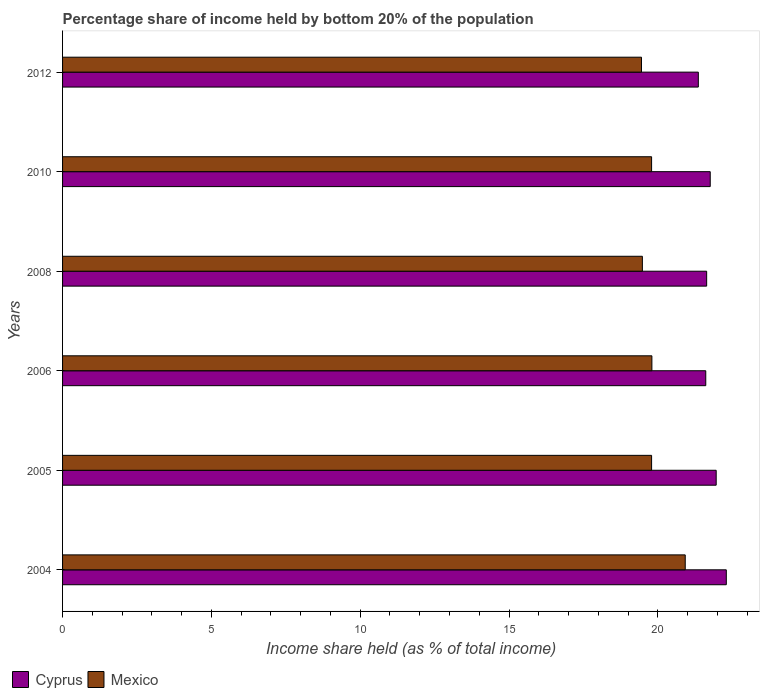How many different coloured bars are there?
Provide a short and direct response. 2. How many groups of bars are there?
Make the answer very short. 6. Are the number of bars on each tick of the Y-axis equal?
Provide a short and direct response. Yes. What is the label of the 6th group of bars from the top?
Ensure brevity in your answer.  2004. What is the share of income held by bottom 20% of the population in Cyprus in 2005?
Give a very brief answer. 21.96. Across all years, what is the maximum share of income held by bottom 20% of the population in Mexico?
Offer a very short reply. 20.92. Across all years, what is the minimum share of income held by bottom 20% of the population in Cyprus?
Your answer should be very brief. 21.36. What is the total share of income held by bottom 20% of the population in Cyprus in the graph?
Offer a terse response. 130.63. What is the difference between the share of income held by bottom 20% of the population in Cyprus in 2004 and that in 2005?
Keep it short and to the point. 0.34. What is the difference between the share of income held by bottom 20% of the population in Cyprus in 2010 and the share of income held by bottom 20% of the population in Mexico in 2012?
Offer a very short reply. 2.31. What is the average share of income held by bottom 20% of the population in Mexico per year?
Give a very brief answer. 19.87. In the year 2008, what is the difference between the share of income held by bottom 20% of the population in Mexico and share of income held by bottom 20% of the population in Cyprus?
Ensure brevity in your answer.  -2.16. In how many years, is the share of income held by bottom 20% of the population in Cyprus greater than 19 %?
Ensure brevity in your answer.  6. What is the ratio of the share of income held by bottom 20% of the population in Mexico in 2005 to that in 2008?
Provide a succinct answer. 1.02. Is the share of income held by bottom 20% of the population in Mexico in 2006 less than that in 2008?
Make the answer very short. No. Is the difference between the share of income held by bottom 20% of the population in Mexico in 2005 and 2008 greater than the difference between the share of income held by bottom 20% of the population in Cyprus in 2005 and 2008?
Make the answer very short. No. What is the difference between the highest and the second highest share of income held by bottom 20% of the population in Mexico?
Your answer should be very brief. 1.12. What is the difference between the highest and the lowest share of income held by bottom 20% of the population in Cyprus?
Ensure brevity in your answer.  0.94. In how many years, is the share of income held by bottom 20% of the population in Mexico greater than the average share of income held by bottom 20% of the population in Mexico taken over all years?
Provide a succinct answer. 1. Is the sum of the share of income held by bottom 20% of the population in Cyprus in 2004 and 2012 greater than the maximum share of income held by bottom 20% of the population in Mexico across all years?
Your answer should be very brief. Yes. What does the 2nd bar from the top in 2005 represents?
Provide a short and direct response. Cyprus. What does the 2nd bar from the bottom in 2010 represents?
Make the answer very short. Mexico. How many bars are there?
Ensure brevity in your answer.  12. Are all the bars in the graph horizontal?
Your answer should be compact. Yes. How many years are there in the graph?
Provide a short and direct response. 6. Does the graph contain any zero values?
Provide a short and direct response. No. How many legend labels are there?
Provide a succinct answer. 2. How are the legend labels stacked?
Your answer should be compact. Horizontal. What is the title of the graph?
Offer a terse response. Percentage share of income held by bottom 20% of the population. Does "Middle East & North Africa (developing only)" appear as one of the legend labels in the graph?
Give a very brief answer. No. What is the label or title of the X-axis?
Keep it short and to the point. Income share held (as % of total income). What is the label or title of the Y-axis?
Your response must be concise. Years. What is the Income share held (as % of total income) of Cyprus in 2004?
Provide a short and direct response. 22.3. What is the Income share held (as % of total income) in Mexico in 2004?
Ensure brevity in your answer.  20.92. What is the Income share held (as % of total income) of Cyprus in 2005?
Offer a very short reply. 21.96. What is the Income share held (as % of total income) of Mexico in 2005?
Keep it short and to the point. 19.79. What is the Income share held (as % of total income) in Cyprus in 2006?
Provide a short and direct response. 21.61. What is the Income share held (as % of total income) of Mexico in 2006?
Your answer should be very brief. 19.8. What is the Income share held (as % of total income) of Cyprus in 2008?
Your answer should be very brief. 21.64. What is the Income share held (as % of total income) of Mexico in 2008?
Make the answer very short. 19.48. What is the Income share held (as % of total income) of Cyprus in 2010?
Your response must be concise. 21.76. What is the Income share held (as % of total income) in Mexico in 2010?
Keep it short and to the point. 19.79. What is the Income share held (as % of total income) of Cyprus in 2012?
Your response must be concise. 21.36. What is the Income share held (as % of total income) in Mexico in 2012?
Ensure brevity in your answer.  19.45. Across all years, what is the maximum Income share held (as % of total income) in Cyprus?
Give a very brief answer. 22.3. Across all years, what is the maximum Income share held (as % of total income) in Mexico?
Give a very brief answer. 20.92. Across all years, what is the minimum Income share held (as % of total income) in Cyprus?
Give a very brief answer. 21.36. Across all years, what is the minimum Income share held (as % of total income) in Mexico?
Provide a short and direct response. 19.45. What is the total Income share held (as % of total income) in Cyprus in the graph?
Provide a succinct answer. 130.63. What is the total Income share held (as % of total income) in Mexico in the graph?
Provide a short and direct response. 119.23. What is the difference between the Income share held (as % of total income) of Cyprus in 2004 and that in 2005?
Ensure brevity in your answer.  0.34. What is the difference between the Income share held (as % of total income) in Mexico in 2004 and that in 2005?
Offer a very short reply. 1.13. What is the difference between the Income share held (as % of total income) in Cyprus in 2004 and that in 2006?
Make the answer very short. 0.69. What is the difference between the Income share held (as % of total income) in Mexico in 2004 and that in 2006?
Provide a succinct answer. 1.12. What is the difference between the Income share held (as % of total income) in Cyprus in 2004 and that in 2008?
Give a very brief answer. 0.66. What is the difference between the Income share held (as % of total income) in Mexico in 2004 and that in 2008?
Keep it short and to the point. 1.44. What is the difference between the Income share held (as % of total income) in Cyprus in 2004 and that in 2010?
Provide a short and direct response. 0.54. What is the difference between the Income share held (as % of total income) in Mexico in 2004 and that in 2010?
Make the answer very short. 1.13. What is the difference between the Income share held (as % of total income) in Cyprus in 2004 and that in 2012?
Your answer should be compact. 0.94. What is the difference between the Income share held (as % of total income) in Mexico in 2004 and that in 2012?
Offer a terse response. 1.47. What is the difference between the Income share held (as % of total income) of Cyprus in 2005 and that in 2006?
Make the answer very short. 0.35. What is the difference between the Income share held (as % of total income) in Mexico in 2005 and that in 2006?
Provide a short and direct response. -0.01. What is the difference between the Income share held (as % of total income) in Cyprus in 2005 and that in 2008?
Keep it short and to the point. 0.32. What is the difference between the Income share held (as % of total income) in Mexico in 2005 and that in 2008?
Offer a terse response. 0.31. What is the difference between the Income share held (as % of total income) of Cyprus in 2005 and that in 2010?
Offer a very short reply. 0.2. What is the difference between the Income share held (as % of total income) in Cyprus in 2005 and that in 2012?
Offer a terse response. 0.6. What is the difference between the Income share held (as % of total income) in Mexico in 2005 and that in 2012?
Offer a very short reply. 0.34. What is the difference between the Income share held (as % of total income) in Cyprus in 2006 and that in 2008?
Your response must be concise. -0.03. What is the difference between the Income share held (as % of total income) in Mexico in 2006 and that in 2008?
Offer a terse response. 0.32. What is the difference between the Income share held (as % of total income) of Cyprus in 2006 and that in 2012?
Provide a short and direct response. 0.25. What is the difference between the Income share held (as % of total income) of Cyprus in 2008 and that in 2010?
Keep it short and to the point. -0.12. What is the difference between the Income share held (as % of total income) of Mexico in 2008 and that in 2010?
Offer a very short reply. -0.31. What is the difference between the Income share held (as % of total income) in Cyprus in 2008 and that in 2012?
Ensure brevity in your answer.  0.28. What is the difference between the Income share held (as % of total income) in Mexico in 2008 and that in 2012?
Provide a short and direct response. 0.03. What is the difference between the Income share held (as % of total income) of Cyprus in 2010 and that in 2012?
Your answer should be compact. 0.4. What is the difference between the Income share held (as % of total income) of Mexico in 2010 and that in 2012?
Make the answer very short. 0.34. What is the difference between the Income share held (as % of total income) of Cyprus in 2004 and the Income share held (as % of total income) of Mexico in 2005?
Make the answer very short. 2.51. What is the difference between the Income share held (as % of total income) in Cyprus in 2004 and the Income share held (as % of total income) in Mexico in 2008?
Your answer should be compact. 2.82. What is the difference between the Income share held (as % of total income) in Cyprus in 2004 and the Income share held (as % of total income) in Mexico in 2010?
Your response must be concise. 2.51. What is the difference between the Income share held (as % of total income) in Cyprus in 2004 and the Income share held (as % of total income) in Mexico in 2012?
Provide a short and direct response. 2.85. What is the difference between the Income share held (as % of total income) of Cyprus in 2005 and the Income share held (as % of total income) of Mexico in 2006?
Your response must be concise. 2.16. What is the difference between the Income share held (as % of total income) in Cyprus in 2005 and the Income share held (as % of total income) in Mexico in 2008?
Give a very brief answer. 2.48. What is the difference between the Income share held (as % of total income) in Cyprus in 2005 and the Income share held (as % of total income) in Mexico in 2010?
Offer a terse response. 2.17. What is the difference between the Income share held (as % of total income) in Cyprus in 2005 and the Income share held (as % of total income) in Mexico in 2012?
Keep it short and to the point. 2.51. What is the difference between the Income share held (as % of total income) in Cyprus in 2006 and the Income share held (as % of total income) in Mexico in 2008?
Your response must be concise. 2.13. What is the difference between the Income share held (as % of total income) in Cyprus in 2006 and the Income share held (as % of total income) in Mexico in 2010?
Make the answer very short. 1.82. What is the difference between the Income share held (as % of total income) in Cyprus in 2006 and the Income share held (as % of total income) in Mexico in 2012?
Offer a very short reply. 2.16. What is the difference between the Income share held (as % of total income) in Cyprus in 2008 and the Income share held (as % of total income) in Mexico in 2010?
Ensure brevity in your answer.  1.85. What is the difference between the Income share held (as % of total income) of Cyprus in 2008 and the Income share held (as % of total income) of Mexico in 2012?
Ensure brevity in your answer.  2.19. What is the difference between the Income share held (as % of total income) of Cyprus in 2010 and the Income share held (as % of total income) of Mexico in 2012?
Keep it short and to the point. 2.31. What is the average Income share held (as % of total income) of Cyprus per year?
Your answer should be compact. 21.77. What is the average Income share held (as % of total income) of Mexico per year?
Offer a very short reply. 19.87. In the year 2004, what is the difference between the Income share held (as % of total income) in Cyprus and Income share held (as % of total income) in Mexico?
Your answer should be very brief. 1.38. In the year 2005, what is the difference between the Income share held (as % of total income) of Cyprus and Income share held (as % of total income) of Mexico?
Offer a terse response. 2.17. In the year 2006, what is the difference between the Income share held (as % of total income) of Cyprus and Income share held (as % of total income) of Mexico?
Make the answer very short. 1.81. In the year 2008, what is the difference between the Income share held (as % of total income) in Cyprus and Income share held (as % of total income) in Mexico?
Ensure brevity in your answer.  2.16. In the year 2010, what is the difference between the Income share held (as % of total income) in Cyprus and Income share held (as % of total income) in Mexico?
Offer a very short reply. 1.97. In the year 2012, what is the difference between the Income share held (as % of total income) in Cyprus and Income share held (as % of total income) in Mexico?
Keep it short and to the point. 1.91. What is the ratio of the Income share held (as % of total income) in Cyprus in 2004 to that in 2005?
Your response must be concise. 1.02. What is the ratio of the Income share held (as % of total income) in Mexico in 2004 to that in 2005?
Provide a short and direct response. 1.06. What is the ratio of the Income share held (as % of total income) of Cyprus in 2004 to that in 2006?
Offer a very short reply. 1.03. What is the ratio of the Income share held (as % of total income) in Mexico in 2004 to that in 2006?
Provide a succinct answer. 1.06. What is the ratio of the Income share held (as % of total income) of Cyprus in 2004 to that in 2008?
Offer a terse response. 1.03. What is the ratio of the Income share held (as % of total income) in Mexico in 2004 to that in 2008?
Keep it short and to the point. 1.07. What is the ratio of the Income share held (as % of total income) in Cyprus in 2004 to that in 2010?
Your answer should be very brief. 1.02. What is the ratio of the Income share held (as % of total income) in Mexico in 2004 to that in 2010?
Offer a very short reply. 1.06. What is the ratio of the Income share held (as % of total income) in Cyprus in 2004 to that in 2012?
Ensure brevity in your answer.  1.04. What is the ratio of the Income share held (as % of total income) in Mexico in 2004 to that in 2012?
Keep it short and to the point. 1.08. What is the ratio of the Income share held (as % of total income) in Cyprus in 2005 to that in 2006?
Give a very brief answer. 1.02. What is the ratio of the Income share held (as % of total income) in Cyprus in 2005 to that in 2008?
Offer a very short reply. 1.01. What is the ratio of the Income share held (as % of total income) in Mexico in 2005 to that in 2008?
Offer a terse response. 1.02. What is the ratio of the Income share held (as % of total income) of Cyprus in 2005 to that in 2010?
Your response must be concise. 1.01. What is the ratio of the Income share held (as % of total income) of Cyprus in 2005 to that in 2012?
Provide a short and direct response. 1.03. What is the ratio of the Income share held (as % of total income) of Mexico in 2005 to that in 2012?
Keep it short and to the point. 1.02. What is the ratio of the Income share held (as % of total income) in Cyprus in 2006 to that in 2008?
Give a very brief answer. 1. What is the ratio of the Income share held (as % of total income) of Mexico in 2006 to that in 2008?
Offer a very short reply. 1.02. What is the ratio of the Income share held (as % of total income) in Mexico in 2006 to that in 2010?
Your response must be concise. 1. What is the ratio of the Income share held (as % of total income) in Cyprus in 2006 to that in 2012?
Make the answer very short. 1.01. What is the ratio of the Income share held (as % of total income) in Mexico in 2008 to that in 2010?
Your answer should be very brief. 0.98. What is the ratio of the Income share held (as % of total income) in Cyprus in 2008 to that in 2012?
Your answer should be very brief. 1.01. What is the ratio of the Income share held (as % of total income) of Mexico in 2008 to that in 2012?
Ensure brevity in your answer.  1. What is the ratio of the Income share held (as % of total income) of Cyprus in 2010 to that in 2012?
Give a very brief answer. 1.02. What is the ratio of the Income share held (as % of total income) in Mexico in 2010 to that in 2012?
Your answer should be compact. 1.02. What is the difference between the highest and the second highest Income share held (as % of total income) of Cyprus?
Make the answer very short. 0.34. What is the difference between the highest and the second highest Income share held (as % of total income) in Mexico?
Your response must be concise. 1.12. What is the difference between the highest and the lowest Income share held (as % of total income) in Cyprus?
Give a very brief answer. 0.94. What is the difference between the highest and the lowest Income share held (as % of total income) of Mexico?
Make the answer very short. 1.47. 